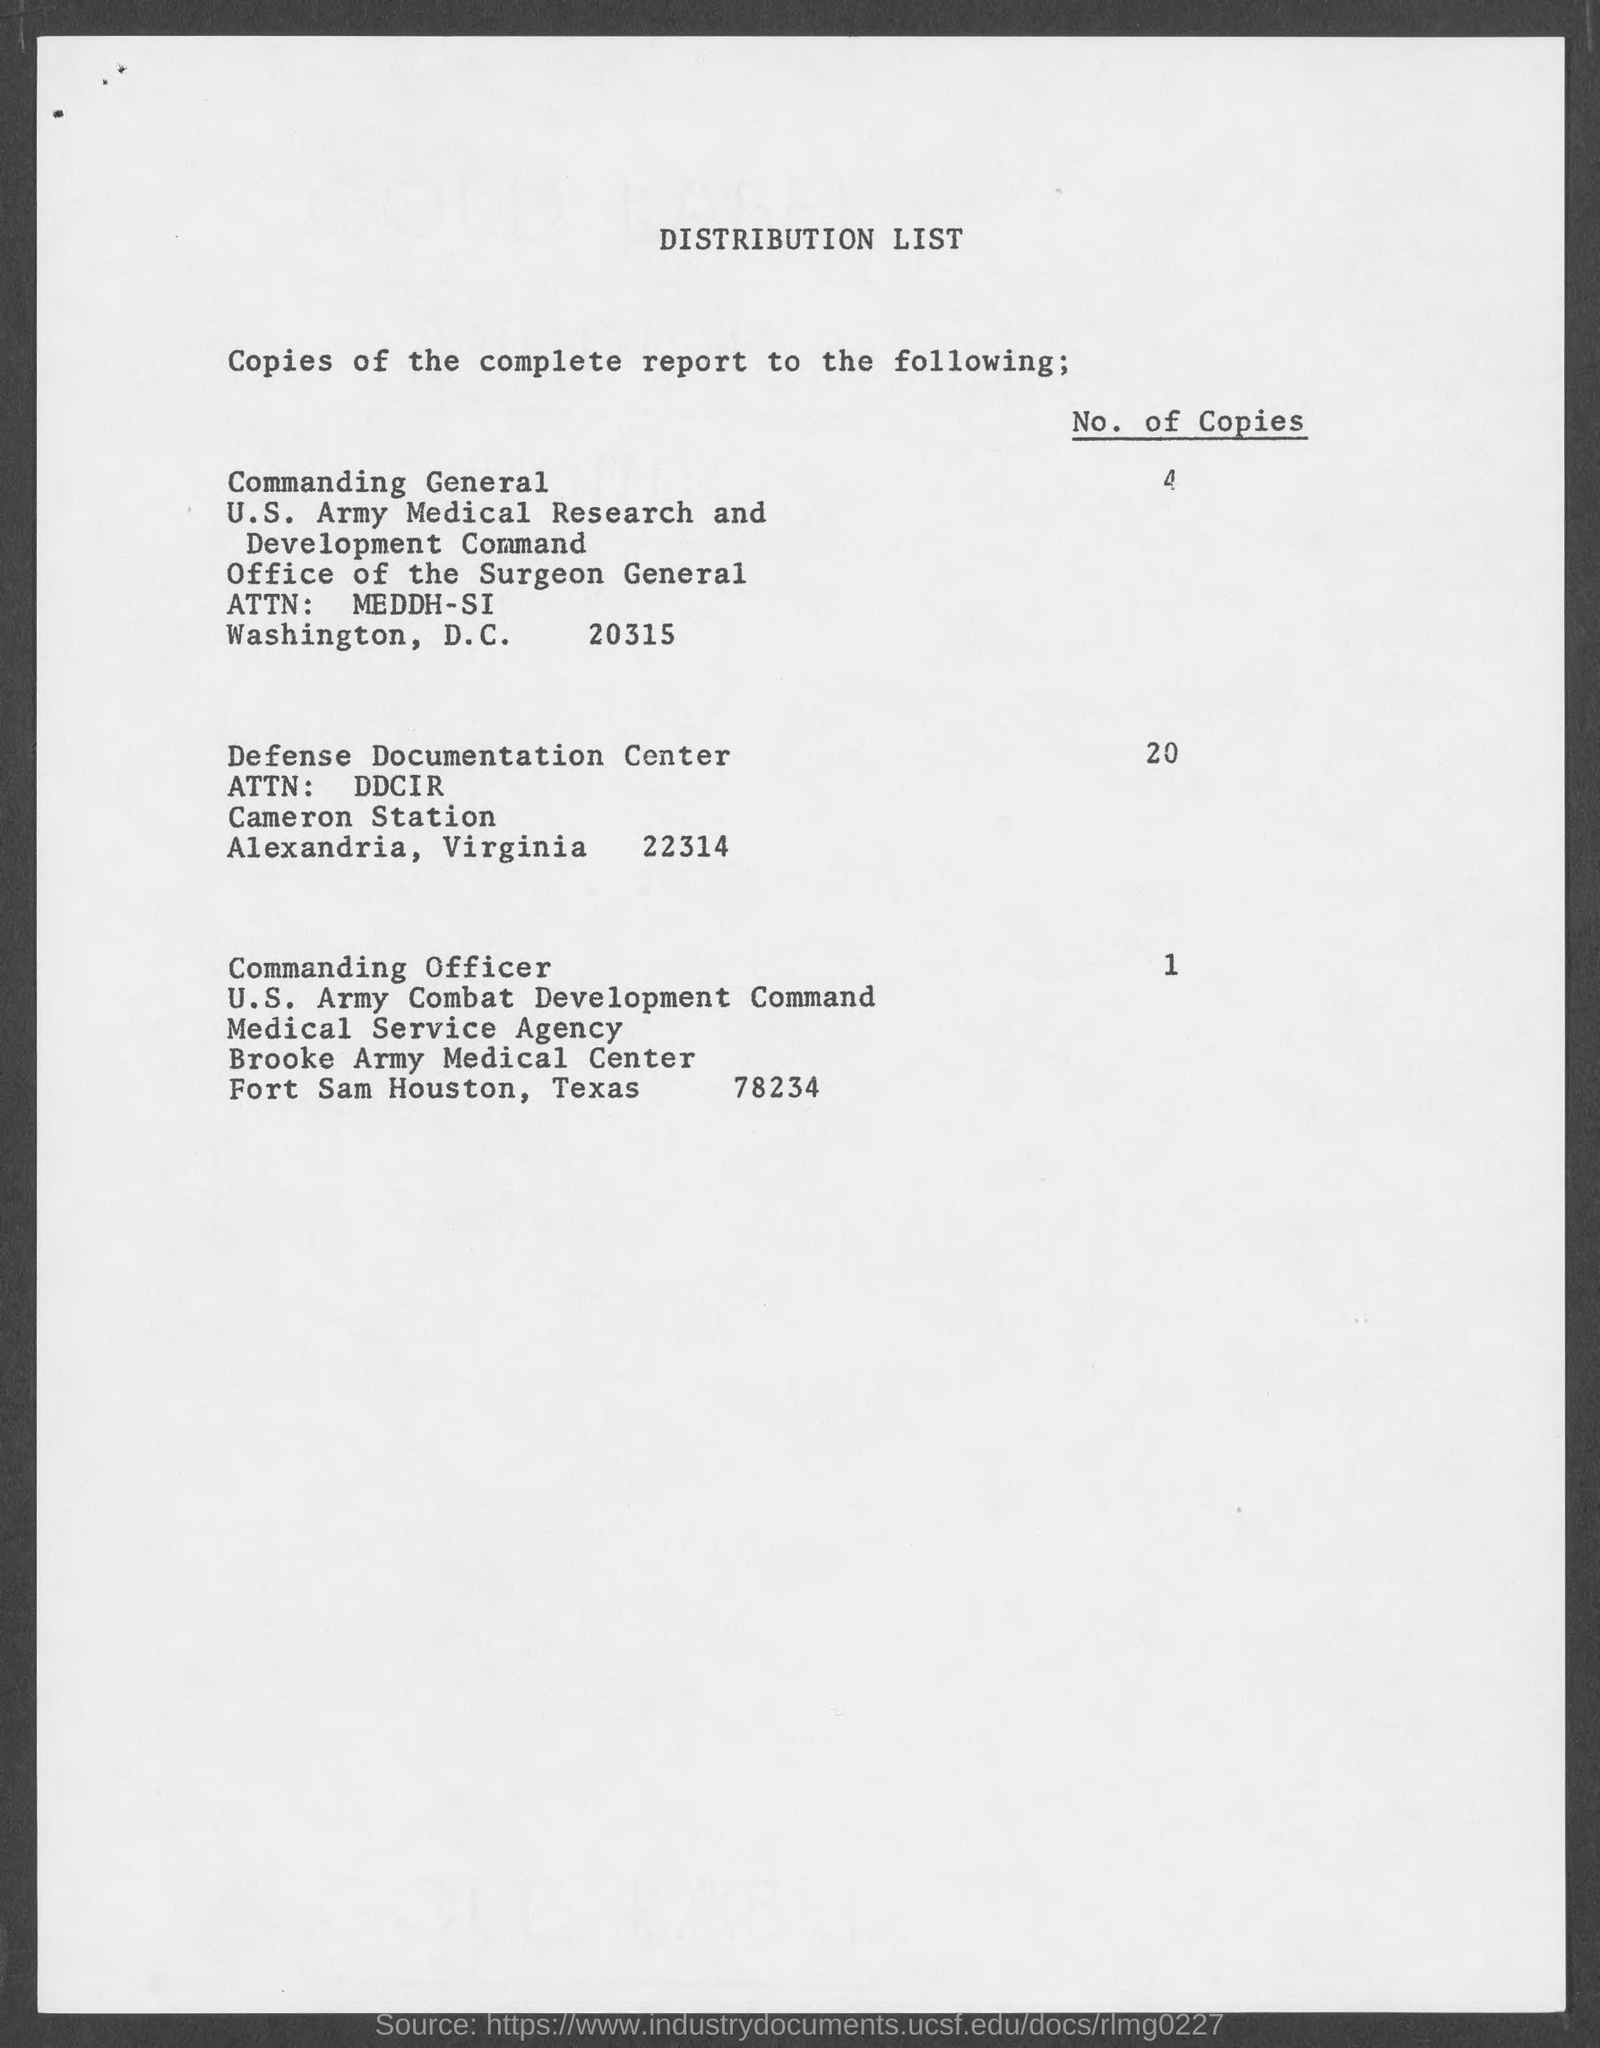how many no. of copies are distributed to Defense documentation center?
 20 